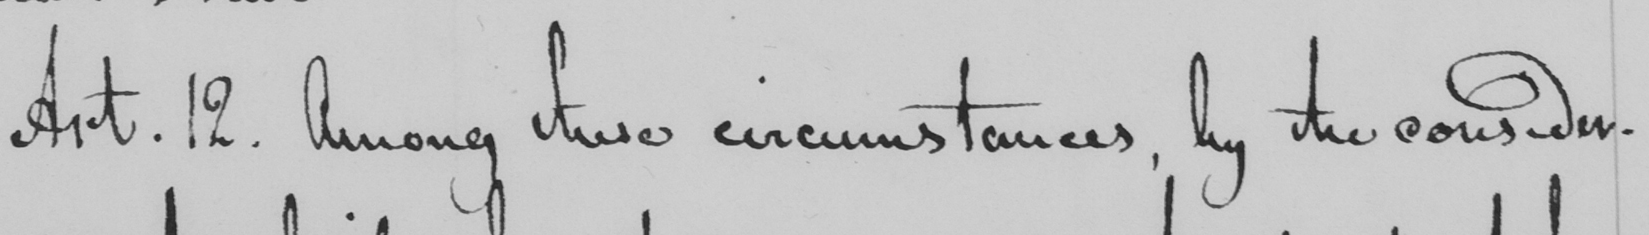What does this handwritten line say? Art. 12. Among two circumstances, by the consider- 